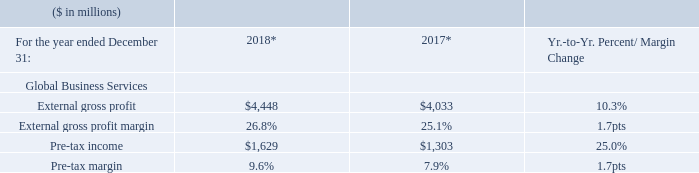* Recast to reflect segment changes.
The year-to-year improvements in margins and pre-tax income in GBS were the result of the shift to higher-value offerings, realignment of resources to key skill areas, increased productivity and utilization as well as a benefit from currency, due to the company’s global delivery model.
What was the Pre-tax income in 2018?
Answer scale should be: million. $1,629. What drove the margins and pre-tax income in GBS improvement? Were the result of the shift to higher-value offerings, realignment of resources to key skill areas, increased productivity and utilization as well as a benefit from currency, due to the company’s global delivery model. What was the gross profit margin in 2018? 26.8%. What is the increase / (decrease) in the external gross profit from 2017 to 2018?
Answer scale should be: million. 4,448 - 4,033
Answer: 415. What is the average Pre-tax income?
Answer scale should be: million. (1,629 + 1,303) / 2
Answer: 1466. What is the increase / (decrease) in the Pre-tax margin from 2017 to 2018?
Answer scale should be: percent. 9.6% - 7.9%
Answer: 1.7. 